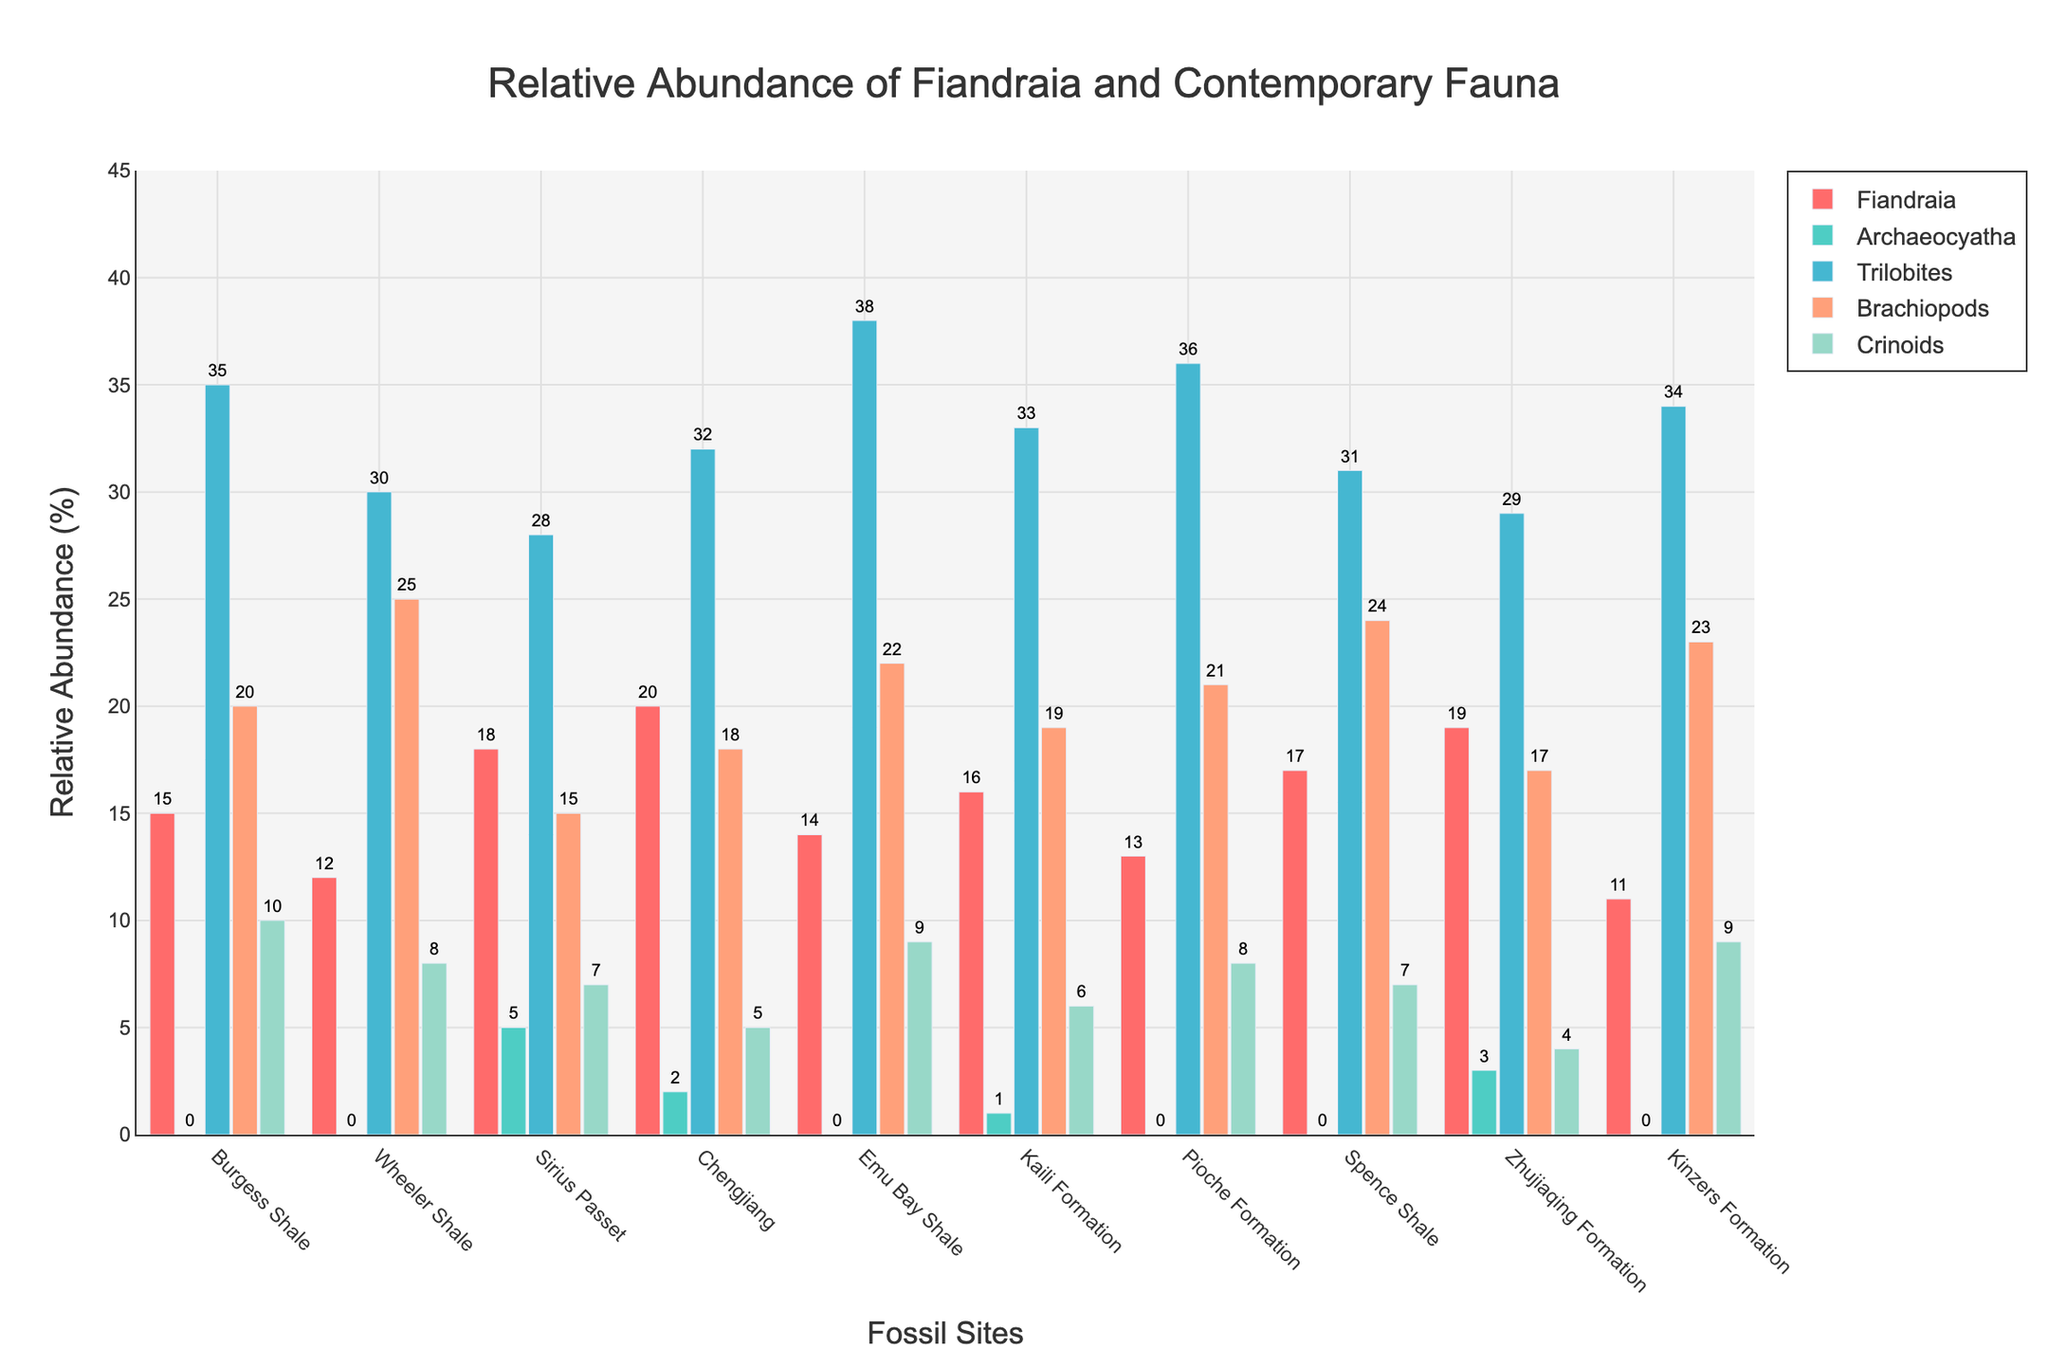What is the most abundant fauna type in the Burgess Shale site? Look at the bars representing the fauna types in the Burgess Shale section. The tallest bar corresponds to Trilobites with a value of 35.
Answer: Trilobites Among the listed sites, where is Fiandraia most abundant? Examine the heights of the Fiandraia bars across all sites. The highest bar for Fiandraia is at Chengjiang with a value of 20.
Answer: Chengjiang What is the average relative abundance of Crinoids across all the sites? Sum up the values for Crinoids across all sites (10 + 8 + 7 + 5 + 9 + 6 + 8 + 7 + 4 + 9 = 73). Then, divide by the number of sites (73 / 10).
Answer: 7.3 Compare the abundance of Fiandraia and Trilobites at the Sirius Passet site. Which one is higher and by how much? Fiandraia has a value of 18 and Trilobites have a value of 28. Subtract the lower value from the higher value (28 - 18).
Answer: Trilobites by 10 How do the relative abundances of Brachiopods and Crinoids at the Pioche Formation compare? The value for Brachiopods is 21, and for Crinoids is 8, compare these two values.
Answer: Brachiopods are more abundant by 13 What is the total relative abundance of all fauna types at the Kinzers Formation site? Sum the values for all fauna types at the Kinzers Formation (11 + 0 + 34 + 23 + 9).
Answer: 77 Which site has the smallest relative abundance of Trilobites, and what is the value? By comparing the heights of all the bars labeled Trilobites across sites, the smallest value is at Zhujiaqing Formation, which is 29.
Answer: Zhujiaqing Formation, 29 How does the relative abundance of Fiandraia at the Emu Bay Shale compare to that at the Kaili Formation? The value for Fiandraia at Emu Bay Shale is 14, and at Kaili Formation is 16. Subtract the smaller value from the larger one (16 - 14).
Answer: Kaili Formation is higher by 2 Among all sites, what is the median value of Fiandraia relative abundance? List the Fiandraia values in ascending order (11, 12, 13, 14, 15, 16, 17, 18, 19, 20). The median is the average of the 5th and 6th values ((15+16)/2).
Answer: 15.5 